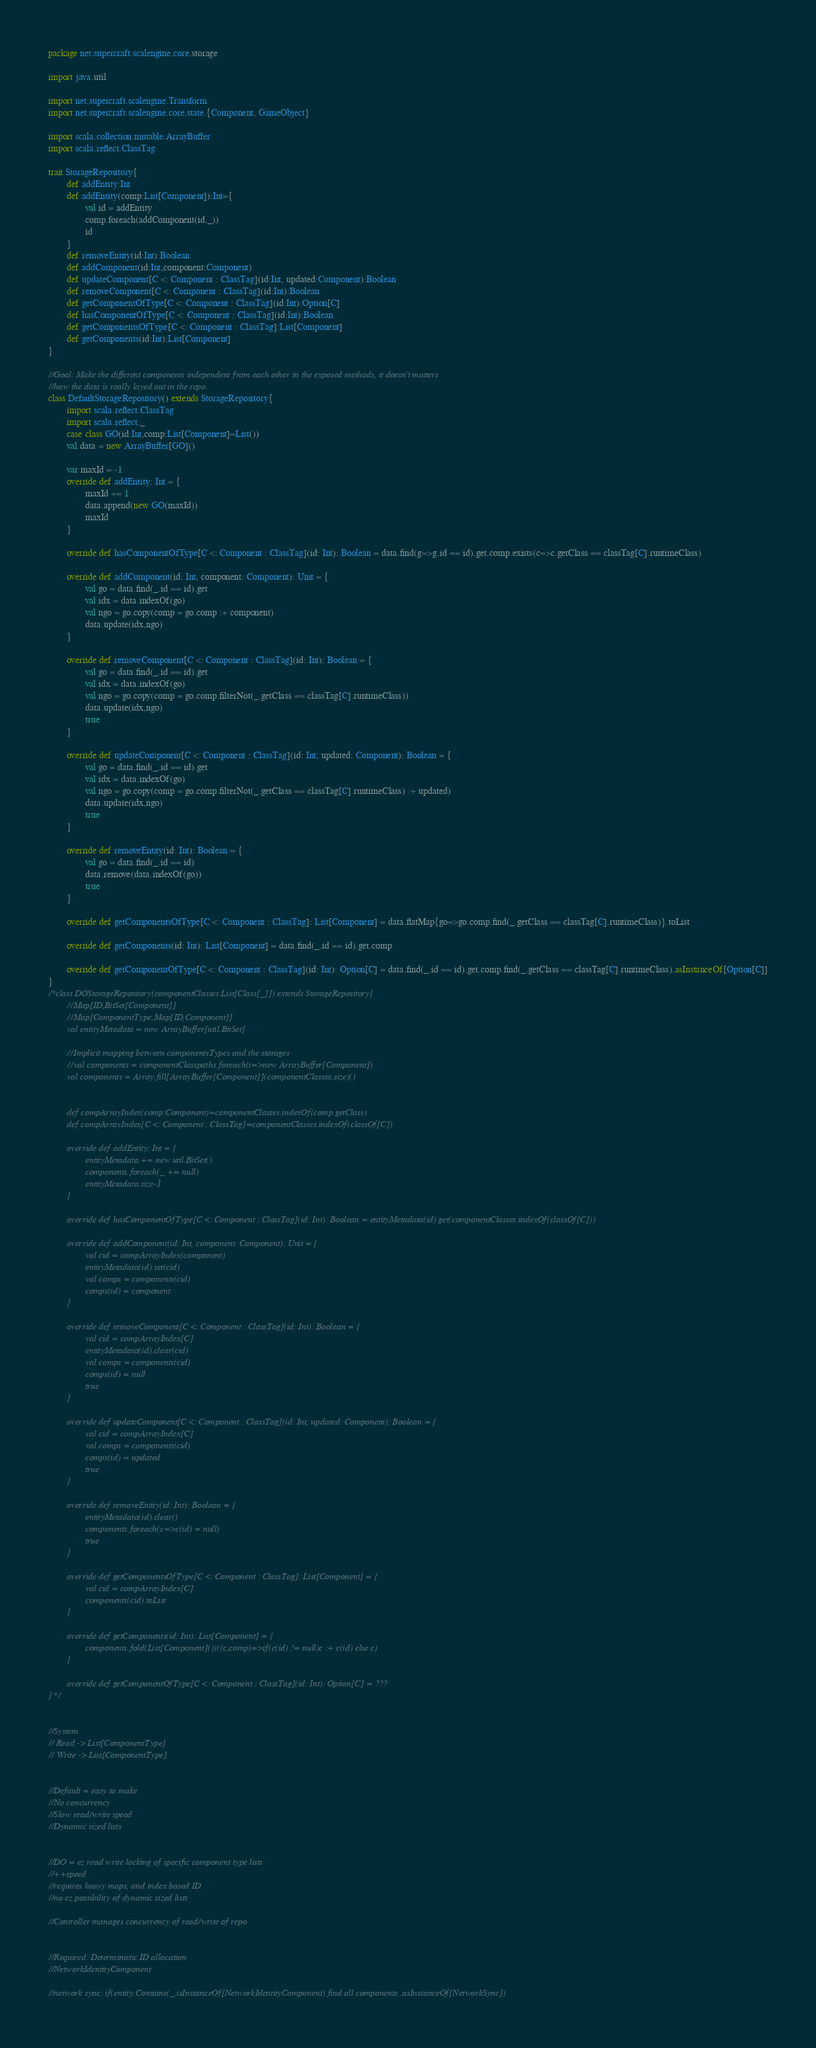Convert code to text. <code><loc_0><loc_0><loc_500><loc_500><_Scala_>package net.supercraft.scalengine.core.storage

import java.util

import net.supercraft.scalengine.Transform
import net.supercraft.scalengine.core.state.{Component, GameObject}

import scala.collection.mutable.ArrayBuffer
import scala.reflect.ClassTag

trait StorageRepository{
		def addEntity:Int
		def addEntity(comp:List[Component]):Int={
				val id = addEntity
				comp.foreach(addComponent(id,_))
				id
		}
		def removeEntity(id:Int):Boolean
		def addComponent(id:Int,component:Component)
		def updateComponent[C <: Component : ClassTag](id:Int, updated:Component):Boolean
		def removeComponent[C <: Component : ClassTag](id:Int):Boolean
		def getComponentOfType[C <: Component : ClassTag](id:Int):Option[C]
		def hasComponentOfType[C <: Component : ClassTag](id:Int):Boolean
		def getComponentsOfType[C <: Component : ClassTag]:List[Component]
		def getComponents(id:Int):List[Component]
}

//Goal: Make the different components independent from each other in the exposed methods, it doesn't matters
//how the data is really layed out in the repo.
class DefaultStorageRepository() extends StorageRepository{
		import scala.reflect.ClassTag
		import scala.reflect._
		case class GO(id:Int,comp:List[Component]=List())
		val data = new ArrayBuffer[GO]()

		var maxId = -1
		override def addEntity: Int = {
				maxId += 1
				data.append(new GO(maxId))
				maxId
		}

		override def hasComponentOfType[C <: Component : ClassTag](id: Int): Boolean = data.find(g=>g.id == id).get.comp.exists(c=>c.getClass == classTag[C].runtimeClass)

		override def addComponent(id: Int, component: Component): Unit = {
				val go = data.find(_.id == id).get
				val idx = data.indexOf(go)
				val ngo = go.copy(comp = go.comp :+ component)
				data.update(idx,ngo)
		}

		override def removeComponent[C <: Component : ClassTag](id: Int): Boolean = {
				val go = data.find(_.id == id).get
				val idx = data.indexOf(go)
				val ngo = go.copy(comp = go.comp.filterNot(_.getClass == classTag[C].runtimeClass))
				data.update(idx,ngo)
				true
		}

		override def updateComponent[C <: Component : ClassTag](id: Int, updated: Component): Boolean = {
				val go = data.find(_.id == id).get
				val idx = data.indexOf(go)
				val ngo = go.copy(comp = go.comp.filterNot(_.getClass == classTag[C].runtimeClass) :+ updated)
				data.update(idx,ngo)
				true
		}

		override def removeEntity(id: Int): Boolean = {
				val go = data.find(_.id == id)
				data.remove(data.indexOf(go))
				true
		}

		override def getComponentsOfType[C <: Component : ClassTag]: List[Component] = data.flatMap{go=>go.comp.find(_.getClass == classTag[C].runtimeClass)}.toList

		override def getComponents(id: Int): List[Component] = data.find(_.id == id).get.comp

		override def getComponentOfType[C <: Component : ClassTag](id: Int): Option[C] = data.find(_.id == id).get.comp.find(_.getClass == classTag[C].runtimeClass).asInstanceOf[Option[C]]
}
/*class DOStorageRepository(componentClasses:List[Class[_]]) extends StorageRepository{
		//Map[ID,BitSet[Component]]
		//Map[ComponentType,Map[ID,Component]]
		val entityMetadata = new ArrayBuffer[util.BitSet]

		//Implicit mapping between componentsTypes and the storages
		//val components = componentClasspaths.foreach(t=>new ArrayBuffer[Component])
		val components = Array.fill[ArrayBuffer[Component]](componentClasses.size)()


		def compArrayIndex(comp:Component)=componentClasses.indexOf(comp.getClass)
		def compArrayIndex[C <: Component : ClassTag]=componentClasses.indexOf(classOf[C])

		override def addEntity: Int = {
				entityMetadata += new util.BitSet()
				components.foreach(_ += null)
				entityMetadata.size-1
		}

		override def hasComponentOfType[C <: Component : ClassTag](id: Int): Boolean = entityMetadata(id).get(componentClasses.indexOf(classOf[C]))

		override def addComponent(id: Int, component: Component): Unit = {
				val cid = compArrayIndex(component)
				entityMetadata(id).set(cid)
				val comps = components(cid)
				comps(id) = component
		}

		override def removeComponent[C <: Component : ClassTag](id: Int): Boolean = {
				val cid = compArrayIndex[C]
				entityMetadata(id).clear(cid)
				val comps = components(cid)
				comps(id) = null
				true
		}

		override def updateComponent[C <: Component : ClassTag](id: Int, updated: Component): Boolean = {
				val cid = compArrayIndex[C]
				val comps = components(cid)
				comps(id) = updated
				true
		}

		override def removeEntity(id: Int): Boolean = {
				entityMetadata(id).clear()
				components.foreach(c=>c(id) = null)
				true
		}

		override def getComponentsOfType[C <: Component : ClassTag]: List[Component] = {
				val cid = compArrayIndex[C]
				components(cid).toList
		}

		override def getComponents(id: Int): List[Component] = {
				components.fold(List[Component]())((c,comp)=>if(c(id) != null)c :+ c(id) else c)
		}

		override def getComponentOfType[C <: Component : ClassTag](id: Int): Option[C] = ???
}*/


//System
// Read -> List[ComponentType]
// Write -> List[ComponentType]


//Default = easy to make
//No concurrency
//Slow read/write speed
//Dynamic sized lists


//DO = ez read write locking of specific component type lists
//++speed
//requires heavy maps, and index based ID
//no ez possibility of dynamic sized lists

//Controller manages concurrency of read/write of repo


//Required: Deterministic ID allocation
//NetworkIdentityComponent

//network sync: if(entity.Contains(_.isInstanceOf[NetworkIdentityComponent) find all components .asInstanceOf[NetworkSync])</code> 